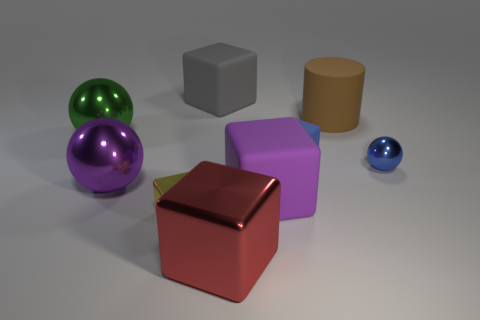Subtract all blue cubes. How many cubes are left? 4 Subtract all purple matte cubes. How many cubes are left? 4 Subtract all yellow cubes. Subtract all gray balls. How many cubes are left? 4 Subtract all blocks. How many objects are left? 4 Add 1 large green objects. How many large green objects exist? 2 Subtract 1 purple blocks. How many objects are left? 8 Subtract all tiny blocks. Subtract all large gray rubber things. How many objects are left? 6 Add 9 purple shiny things. How many purple shiny things are left? 10 